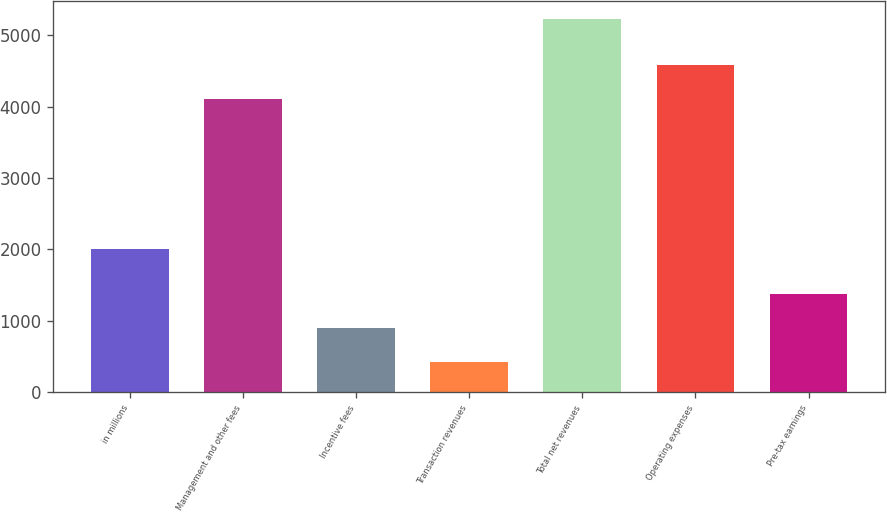Convert chart to OTSL. <chart><loc_0><loc_0><loc_500><loc_500><bar_chart><fcel>in millions<fcel>Management and other fees<fcel>Incentive fees<fcel>Transaction revenues<fcel>Total net revenues<fcel>Operating expenses<fcel>Pre-tax earnings<nl><fcel>2012<fcel>4105<fcel>896.6<fcel>416<fcel>5222<fcel>4585.6<fcel>1377.2<nl></chart> 